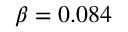Convert formula to latex. <formula><loc_0><loc_0><loc_500><loc_500>\beta = 0 . 0 8 4</formula> 